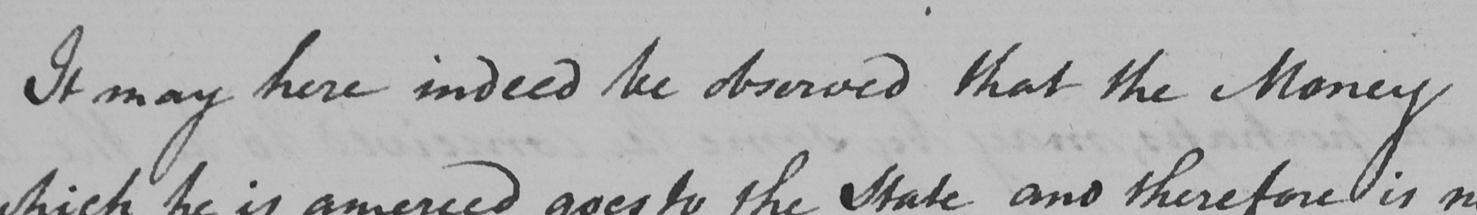Please transcribe the handwritten text in this image. It may here indeed be observed that the Money 